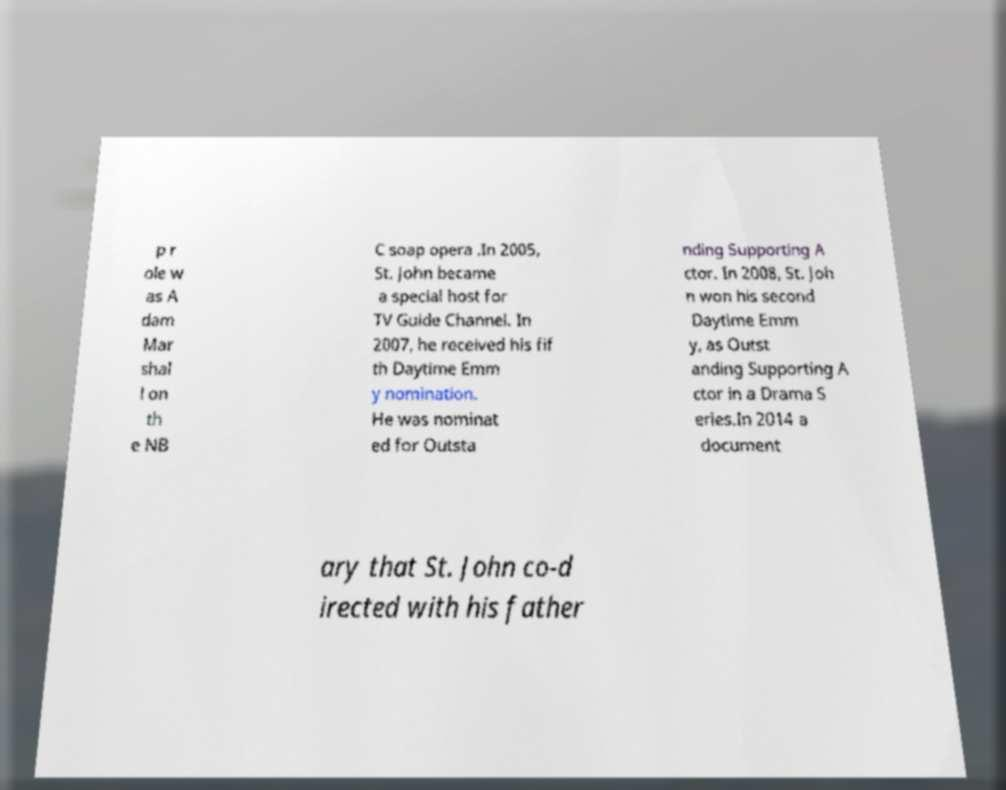There's text embedded in this image that I need extracted. Can you transcribe it verbatim? p r ole w as A dam Mar shal l on th e NB C soap opera .In 2005, St. John became a special host for TV Guide Channel. In 2007, he received his fif th Daytime Emm y nomination. He was nominat ed for Outsta nding Supporting A ctor. In 2008, St. Joh n won his second Daytime Emm y, as Outst anding Supporting A ctor in a Drama S eries.In 2014 a document ary that St. John co-d irected with his father 